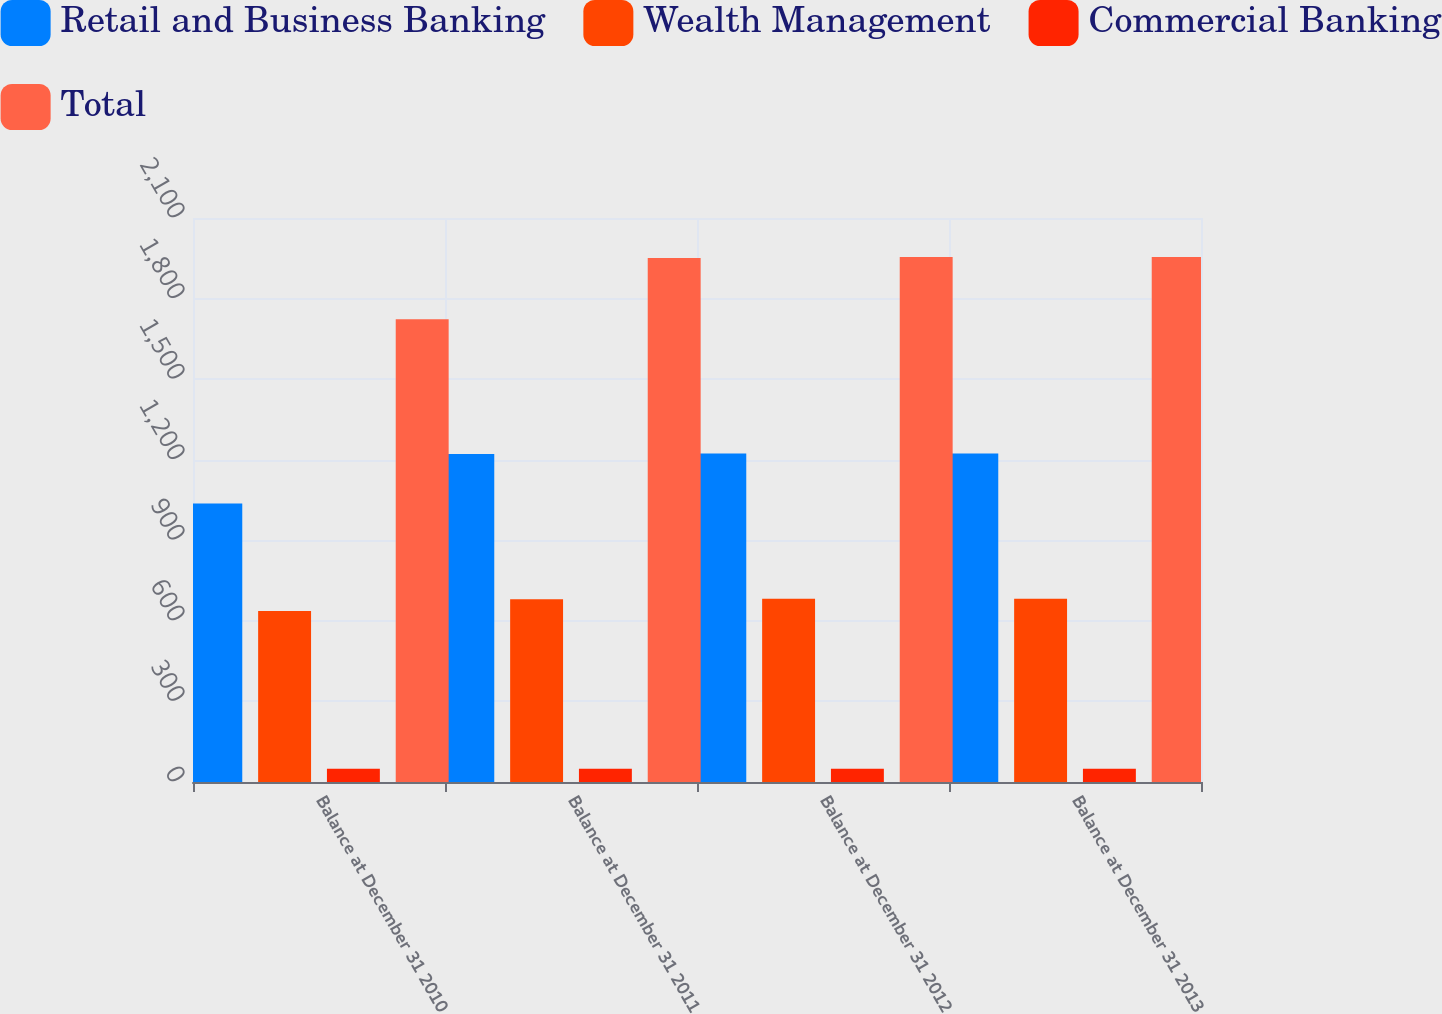Convert chart to OTSL. <chart><loc_0><loc_0><loc_500><loc_500><stacked_bar_chart><ecel><fcel>Balance at December 31 2010<fcel>Balance at December 31 2011<fcel>Balance at December 31 2012<fcel>Balance at December 31 2013<nl><fcel>Retail and Business Banking<fcel>1037.1<fcel>1220.9<fcel>1222.8<fcel>1222.8<nl><fcel>Wealth Management<fcel>636.5<fcel>680.7<fcel>681.9<fcel>681.9<nl><fcel>Commercial Banking<fcel>49.8<fcel>49.8<fcel>49.8<fcel>49.8<nl><fcel>Total<fcel>1723.4<fcel>1951.4<fcel>1954.5<fcel>1954.5<nl></chart> 